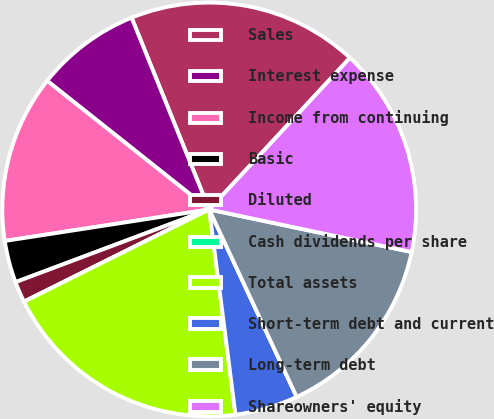Convert chart to OTSL. <chart><loc_0><loc_0><loc_500><loc_500><pie_chart><fcel>Sales<fcel>Interest expense<fcel>Income from continuing<fcel>Basic<fcel>Diluted<fcel>Cash dividends per share<fcel>Total assets<fcel>Short-term debt and current<fcel>Long-term debt<fcel>Shareowners' equity<nl><fcel>18.03%<fcel>8.2%<fcel>13.11%<fcel>3.28%<fcel>1.64%<fcel>0.0%<fcel>19.67%<fcel>4.92%<fcel>14.75%<fcel>16.39%<nl></chart> 